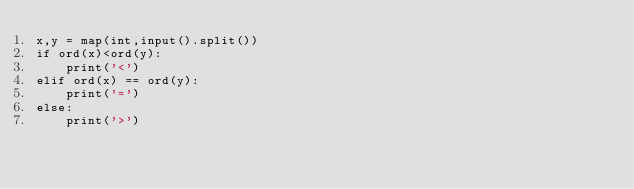Convert code to text. <code><loc_0><loc_0><loc_500><loc_500><_Python_>x,y = map(int,input().split())
if ord(x)<ord(y):
    print('<')
elif ord(x) == ord(y):
    print('=')
else:
    print('>')
</code> 